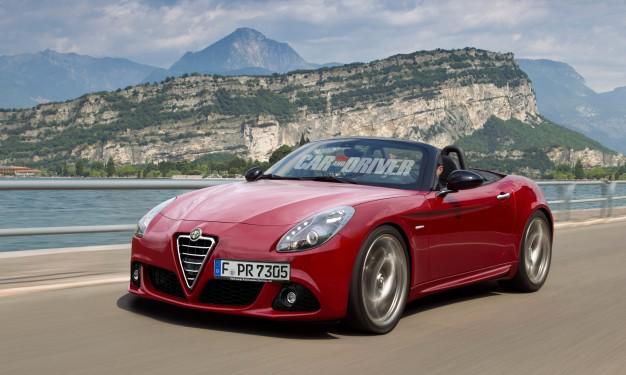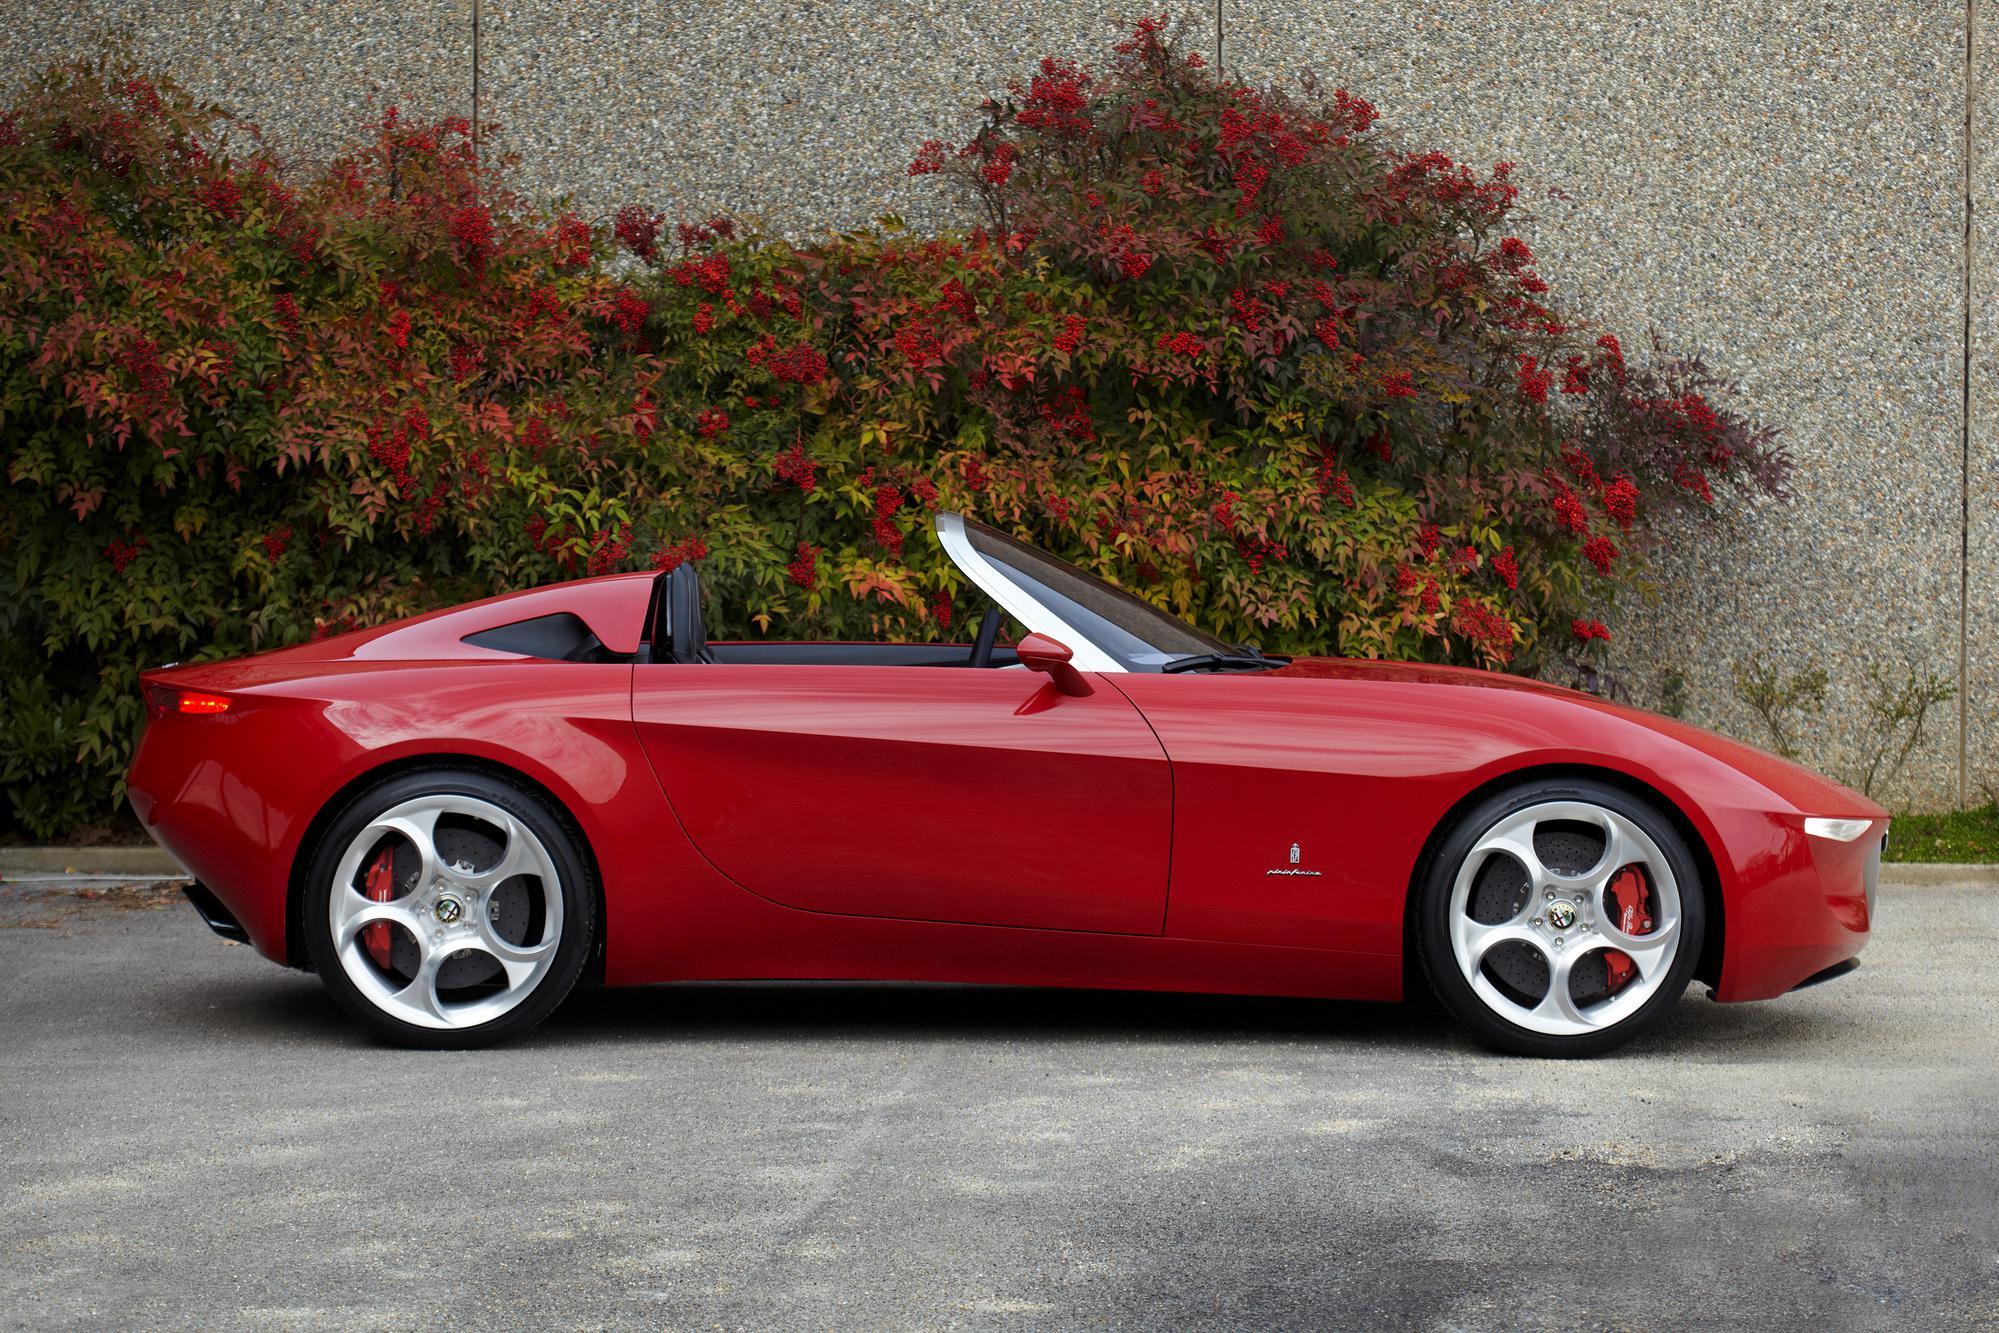The first image is the image on the left, the second image is the image on the right. For the images shown, is this caption "The left image shows a driver behind the wheel of a topless red convertible." true? Answer yes or no. Yes. 